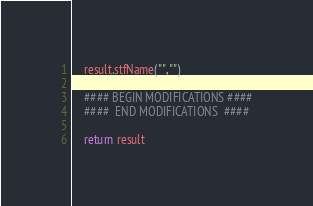Convert code to text. <code><loc_0><loc_0><loc_500><loc_500><_Python_>	result.stfName("","")		
	
	#### BEGIN MODIFICATIONS ####
	####  END MODIFICATIONS  ####
	
	return result</code> 